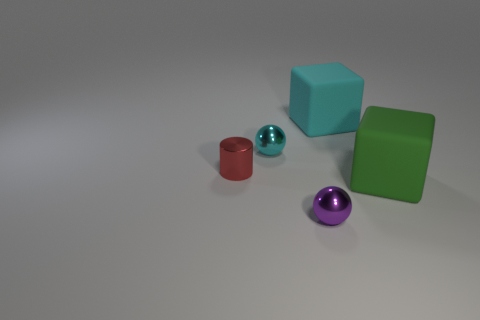Add 3 cyan things. How many objects exist? 8 Subtract all cubes. How many objects are left? 3 Subtract 0 gray blocks. How many objects are left? 5 Subtract all purple metallic spheres. Subtract all big cyan things. How many objects are left? 3 Add 1 red shiny cylinders. How many red shiny cylinders are left? 2 Add 5 red things. How many red things exist? 6 